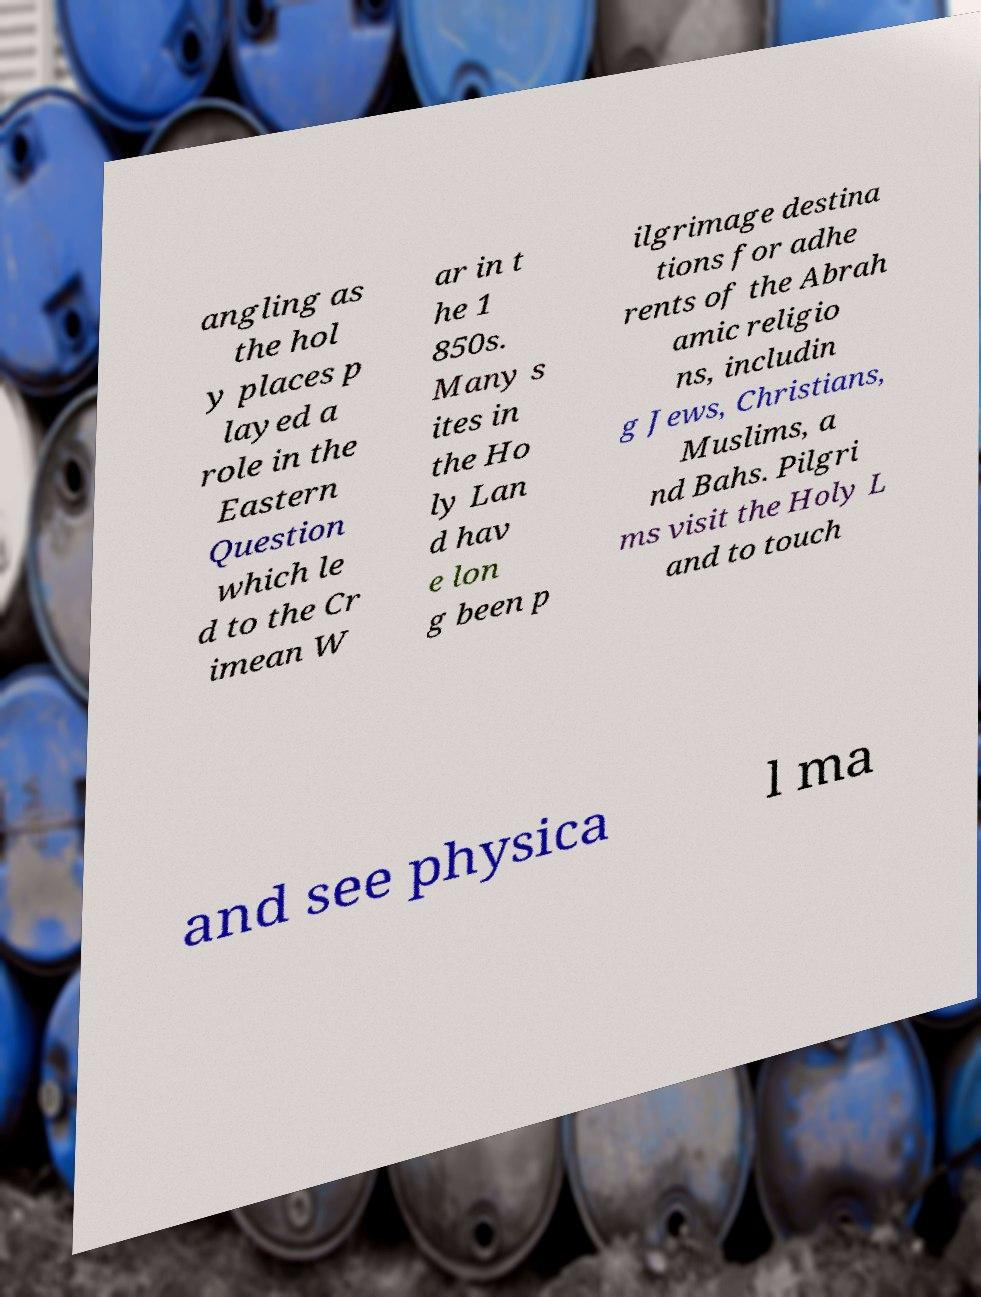Could you assist in decoding the text presented in this image and type it out clearly? angling as the hol y places p layed a role in the Eastern Question which le d to the Cr imean W ar in t he 1 850s. Many s ites in the Ho ly Lan d hav e lon g been p ilgrimage destina tions for adhe rents of the Abrah amic religio ns, includin g Jews, Christians, Muslims, a nd Bahs. Pilgri ms visit the Holy L and to touch and see physica l ma 